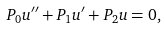Convert formula to latex. <formula><loc_0><loc_0><loc_500><loc_500>P _ { 0 } u ^ { \prime \prime } + P _ { 1 } u ^ { \prime } + P _ { 2 } u = 0 ,</formula> 